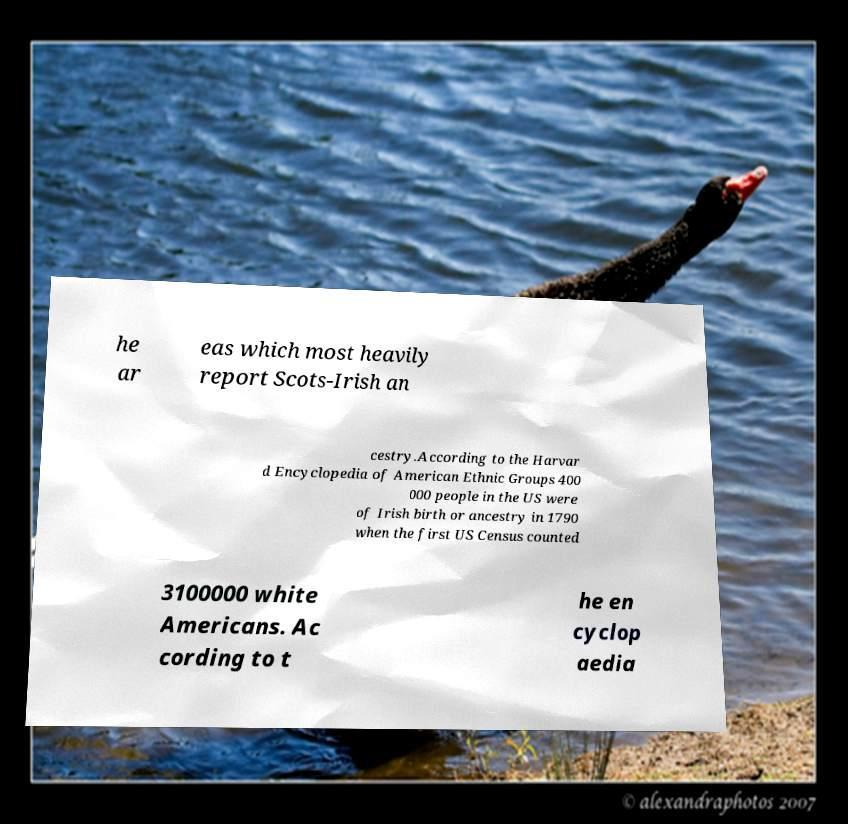I need the written content from this picture converted into text. Can you do that? he ar eas which most heavily report Scots-Irish an cestry.According to the Harvar d Encyclopedia of American Ethnic Groups 400 000 people in the US were of Irish birth or ancestry in 1790 when the first US Census counted 3100000 white Americans. Ac cording to t he en cyclop aedia 